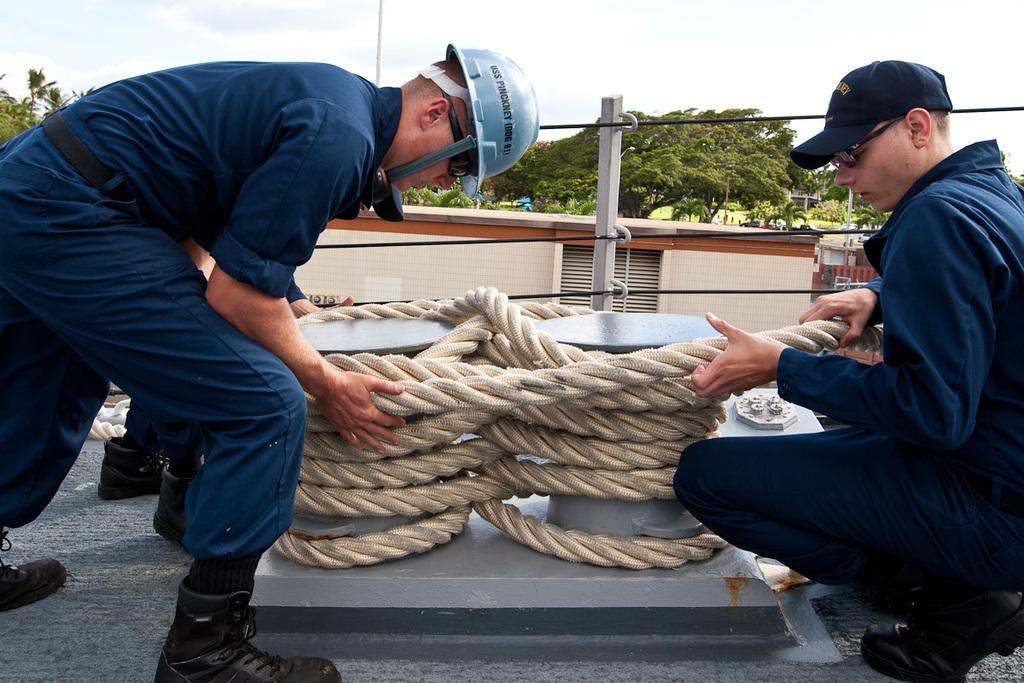Please provide a concise description of this image. In this image there is the sky towards the top of the image, there are trees, there is a wall, there is a pole, there are wires, there are three men, two of them are wearing caps, one of them is wearing a helmet, there is a carpet on the floor, there is an object on the carpet. 